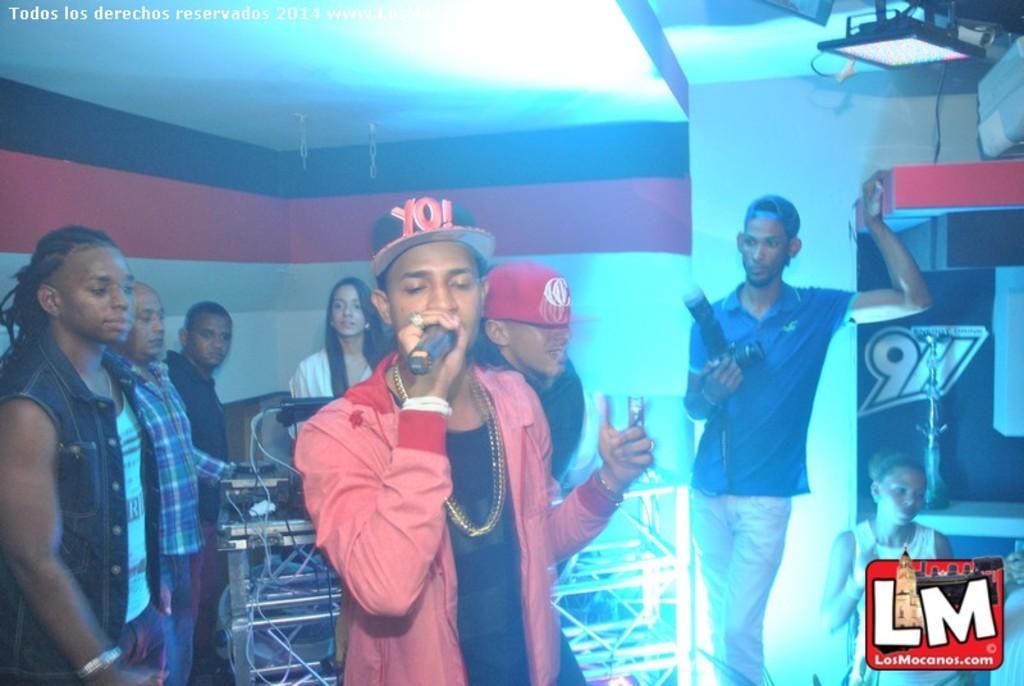Describe this image in one or two sentences. This image is taken indoors. At the top of the image there is a roof. In the background there is a wall. There is a board with a text on it. There is a mic on the table. At the top right of the image there is a light. At the right bottom of the image there is a watermark. A woman is sitting on the chair. In the middle of the image a few people are standing. There are a few devices on the table. A man is standing and holding a mic in his hand and he is singing. A man is standing and holding a camera in his hand. 